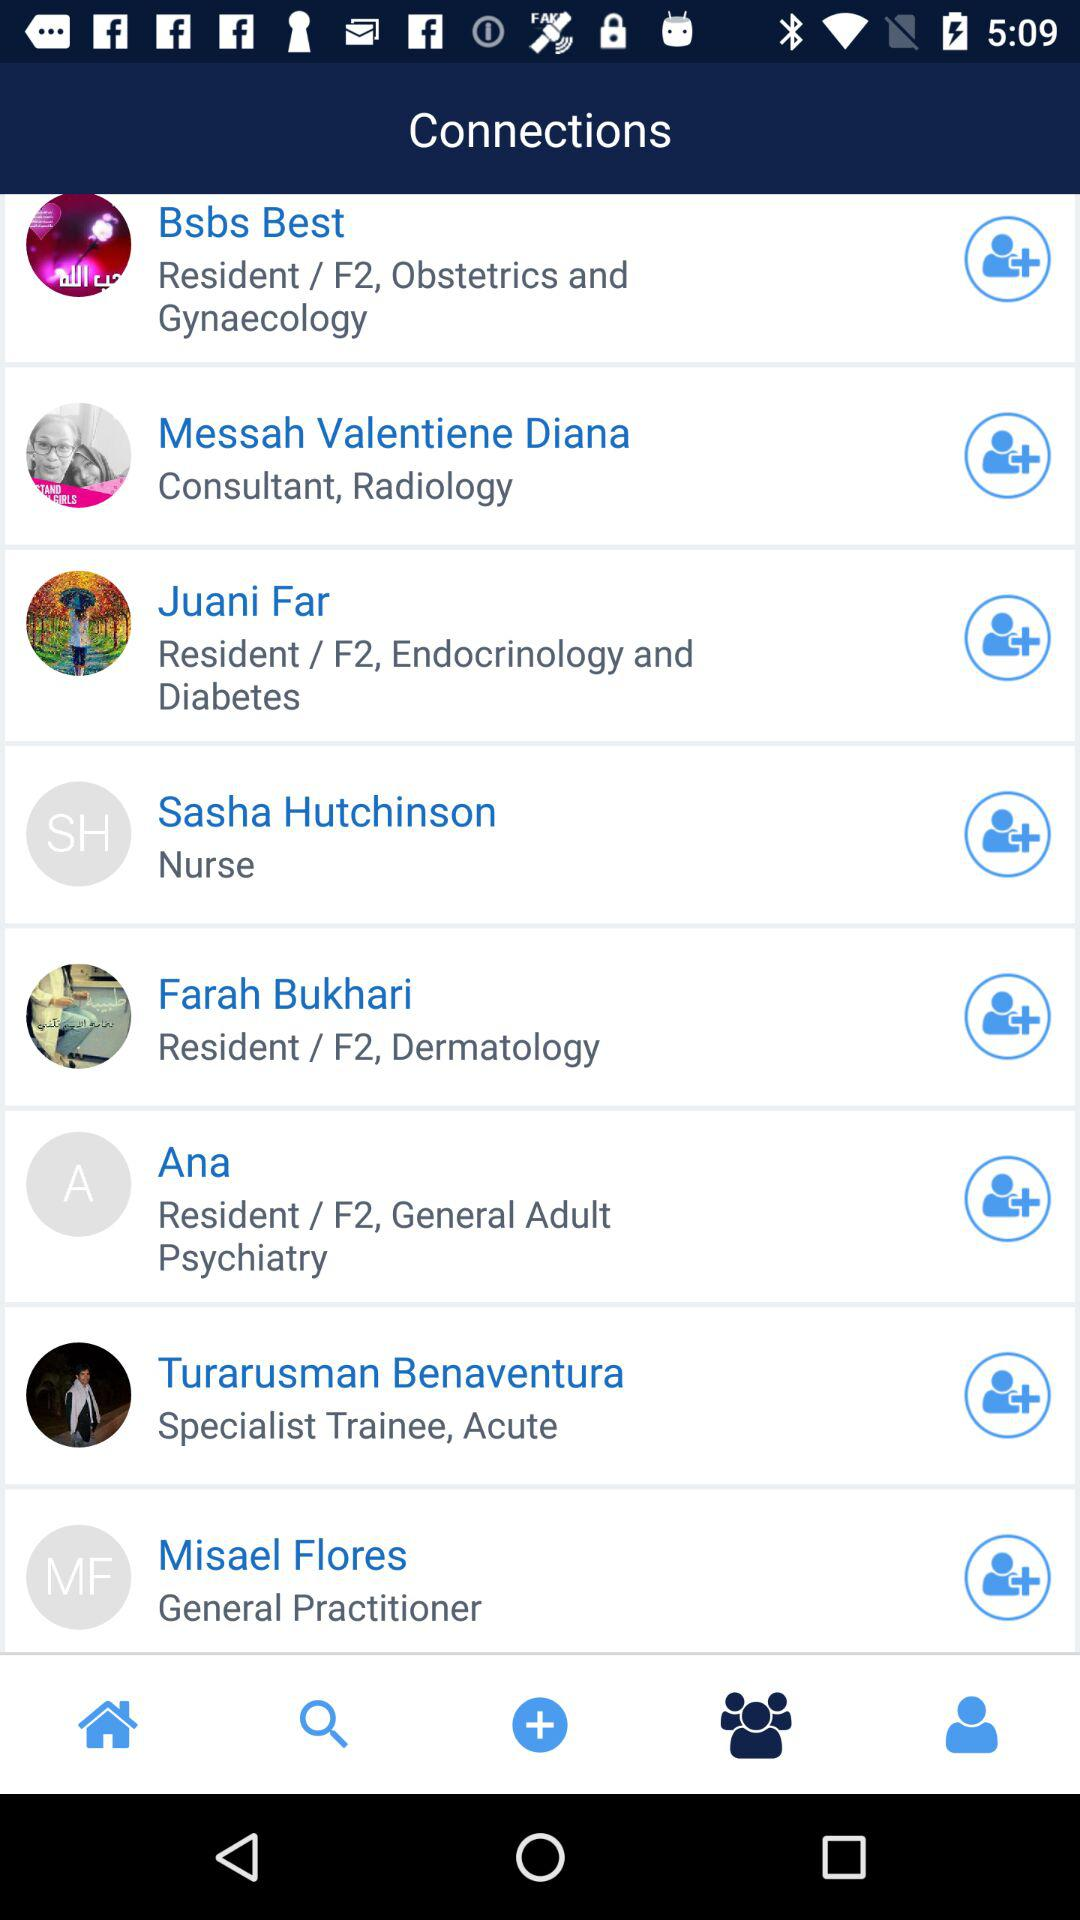Which tab is selected? The selected tab is "Connections". 